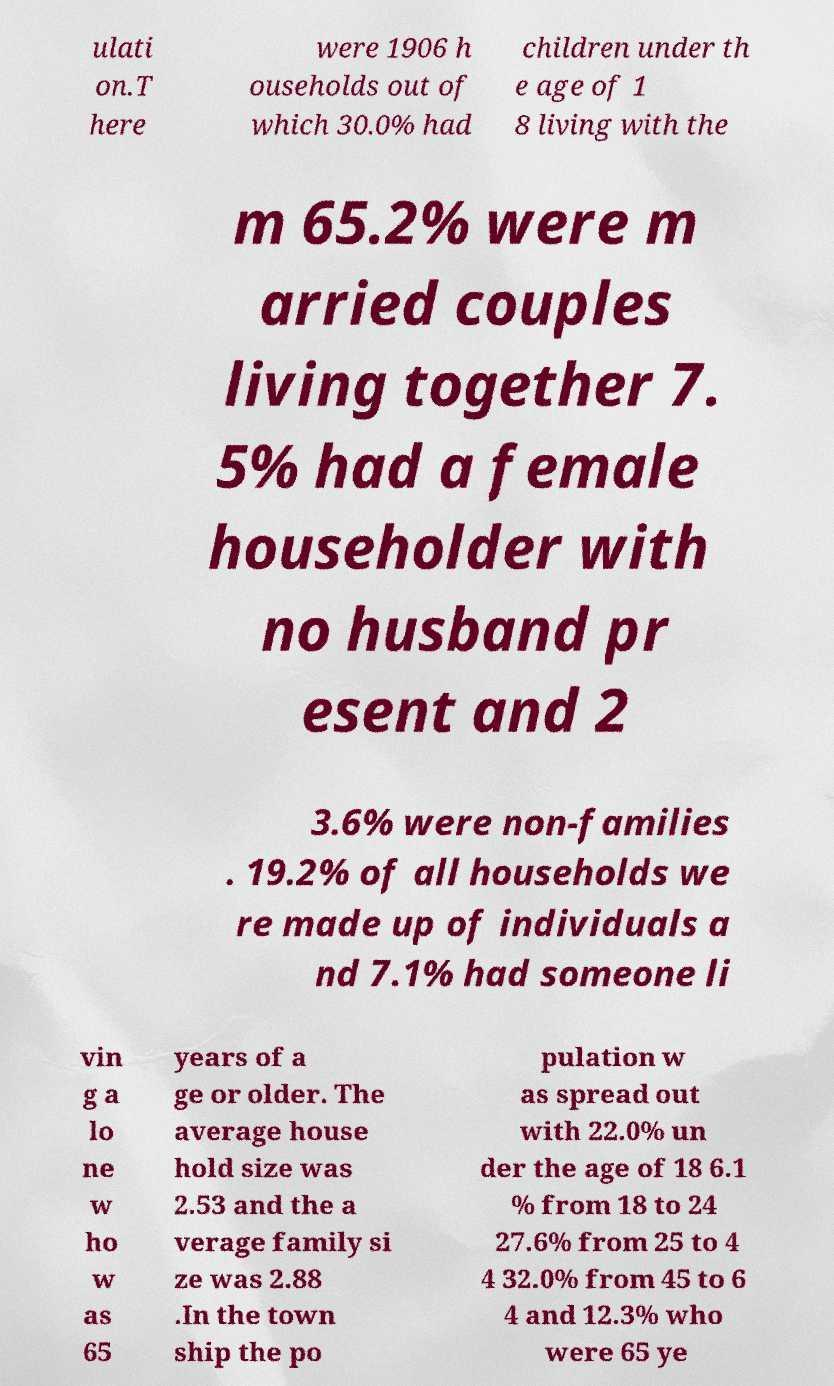Could you extract and type out the text from this image? ulati on.T here were 1906 h ouseholds out of which 30.0% had children under th e age of 1 8 living with the m 65.2% were m arried couples living together 7. 5% had a female householder with no husband pr esent and 2 3.6% were non-families . 19.2% of all households we re made up of individuals a nd 7.1% had someone li vin g a lo ne w ho w as 65 years of a ge or older. The average house hold size was 2.53 and the a verage family si ze was 2.88 .In the town ship the po pulation w as spread out with 22.0% un der the age of 18 6.1 % from 18 to 24 27.6% from 25 to 4 4 32.0% from 45 to 6 4 and 12.3% who were 65 ye 